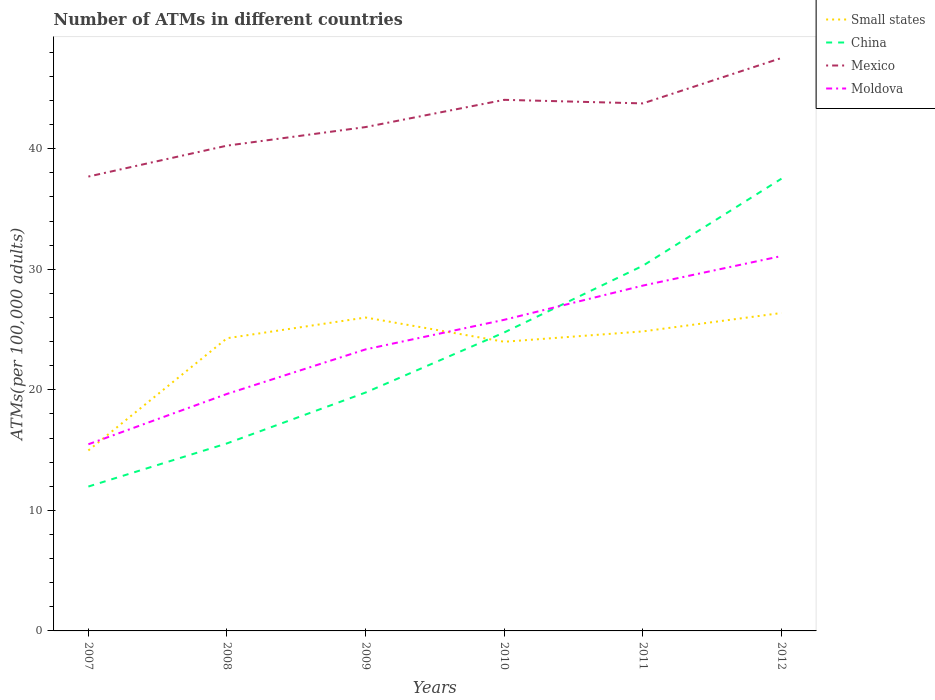Is the number of lines equal to the number of legend labels?
Offer a very short reply. Yes. Across all years, what is the maximum number of ATMs in Mexico?
Provide a short and direct response. 37.69. What is the total number of ATMs in Small states in the graph?
Make the answer very short. -0.38. What is the difference between the highest and the second highest number of ATMs in Small states?
Offer a terse response. 11.4. What is the difference between the highest and the lowest number of ATMs in Small states?
Provide a short and direct response. 5. How many lines are there?
Provide a short and direct response. 4. How many years are there in the graph?
Provide a succinct answer. 6. Are the values on the major ticks of Y-axis written in scientific E-notation?
Provide a succinct answer. No. Does the graph contain any zero values?
Provide a short and direct response. No. Where does the legend appear in the graph?
Keep it short and to the point. Top right. How many legend labels are there?
Offer a very short reply. 4. What is the title of the graph?
Make the answer very short. Number of ATMs in different countries. What is the label or title of the Y-axis?
Offer a terse response. ATMs(per 100,0 adults). What is the ATMs(per 100,000 adults) in Small states in 2007?
Make the answer very short. 14.97. What is the ATMs(per 100,000 adults) in China in 2007?
Your answer should be very brief. 11.98. What is the ATMs(per 100,000 adults) of Mexico in 2007?
Give a very brief answer. 37.69. What is the ATMs(per 100,000 adults) of Moldova in 2007?
Offer a very short reply. 15.48. What is the ATMs(per 100,000 adults) in Small states in 2008?
Provide a succinct answer. 24.28. What is the ATMs(per 100,000 adults) in China in 2008?
Your answer should be very brief. 15.55. What is the ATMs(per 100,000 adults) of Mexico in 2008?
Ensure brevity in your answer.  40.25. What is the ATMs(per 100,000 adults) in Moldova in 2008?
Offer a very short reply. 19.66. What is the ATMs(per 100,000 adults) in Small states in 2009?
Ensure brevity in your answer.  26. What is the ATMs(per 100,000 adults) in China in 2009?
Your answer should be very brief. 19.77. What is the ATMs(per 100,000 adults) of Mexico in 2009?
Make the answer very short. 41.79. What is the ATMs(per 100,000 adults) in Moldova in 2009?
Provide a short and direct response. 23.35. What is the ATMs(per 100,000 adults) of Small states in 2010?
Provide a short and direct response. 23.99. What is the ATMs(per 100,000 adults) of China in 2010?
Your response must be concise. 24.76. What is the ATMs(per 100,000 adults) of Mexico in 2010?
Your answer should be very brief. 44.05. What is the ATMs(per 100,000 adults) in Moldova in 2010?
Your response must be concise. 25.81. What is the ATMs(per 100,000 adults) of Small states in 2011?
Provide a succinct answer. 24.84. What is the ATMs(per 100,000 adults) of China in 2011?
Offer a very short reply. 30.29. What is the ATMs(per 100,000 adults) of Mexico in 2011?
Ensure brevity in your answer.  43.76. What is the ATMs(per 100,000 adults) in Moldova in 2011?
Offer a very short reply. 28.64. What is the ATMs(per 100,000 adults) in Small states in 2012?
Your response must be concise. 26.37. What is the ATMs(per 100,000 adults) in China in 2012?
Your response must be concise. 37.51. What is the ATMs(per 100,000 adults) in Mexico in 2012?
Ensure brevity in your answer.  47.52. What is the ATMs(per 100,000 adults) in Moldova in 2012?
Ensure brevity in your answer.  31.1. Across all years, what is the maximum ATMs(per 100,000 adults) in Small states?
Ensure brevity in your answer.  26.37. Across all years, what is the maximum ATMs(per 100,000 adults) of China?
Offer a terse response. 37.51. Across all years, what is the maximum ATMs(per 100,000 adults) of Mexico?
Offer a very short reply. 47.52. Across all years, what is the maximum ATMs(per 100,000 adults) in Moldova?
Make the answer very short. 31.1. Across all years, what is the minimum ATMs(per 100,000 adults) of Small states?
Provide a succinct answer. 14.97. Across all years, what is the minimum ATMs(per 100,000 adults) of China?
Keep it short and to the point. 11.98. Across all years, what is the minimum ATMs(per 100,000 adults) of Mexico?
Provide a succinct answer. 37.69. Across all years, what is the minimum ATMs(per 100,000 adults) of Moldova?
Your answer should be very brief. 15.48. What is the total ATMs(per 100,000 adults) of Small states in the graph?
Offer a very short reply. 140.44. What is the total ATMs(per 100,000 adults) of China in the graph?
Your response must be concise. 139.86. What is the total ATMs(per 100,000 adults) of Mexico in the graph?
Your answer should be compact. 255.06. What is the total ATMs(per 100,000 adults) of Moldova in the graph?
Offer a terse response. 144.04. What is the difference between the ATMs(per 100,000 adults) of Small states in 2007 and that in 2008?
Provide a succinct answer. -9.31. What is the difference between the ATMs(per 100,000 adults) in China in 2007 and that in 2008?
Provide a short and direct response. -3.58. What is the difference between the ATMs(per 100,000 adults) of Mexico in 2007 and that in 2008?
Ensure brevity in your answer.  -2.56. What is the difference between the ATMs(per 100,000 adults) in Moldova in 2007 and that in 2008?
Offer a very short reply. -4.18. What is the difference between the ATMs(per 100,000 adults) of Small states in 2007 and that in 2009?
Give a very brief answer. -11.03. What is the difference between the ATMs(per 100,000 adults) of China in 2007 and that in 2009?
Provide a succinct answer. -7.8. What is the difference between the ATMs(per 100,000 adults) in Mexico in 2007 and that in 2009?
Your answer should be compact. -4.11. What is the difference between the ATMs(per 100,000 adults) in Moldova in 2007 and that in 2009?
Offer a terse response. -7.87. What is the difference between the ATMs(per 100,000 adults) of Small states in 2007 and that in 2010?
Offer a terse response. -9.02. What is the difference between the ATMs(per 100,000 adults) of China in 2007 and that in 2010?
Keep it short and to the point. -12.78. What is the difference between the ATMs(per 100,000 adults) of Mexico in 2007 and that in 2010?
Offer a terse response. -6.37. What is the difference between the ATMs(per 100,000 adults) of Moldova in 2007 and that in 2010?
Provide a short and direct response. -10.32. What is the difference between the ATMs(per 100,000 adults) in Small states in 2007 and that in 2011?
Offer a terse response. -9.87. What is the difference between the ATMs(per 100,000 adults) of China in 2007 and that in 2011?
Make the answer very short. -18.31. What is the difference between the ATMs(per 100,000 adults) in Mexico in 2007 and that in 2011?
Give a very brief answer. -6.07. What is the difference between the ATMs(per 100,000 adults) of Moldova in 2007 and that in 2011?
Your response must be concise. -13.16. What is the difference between the ATMs(per 100,000 adults) of Small states in 2007 and that in 2012?
Your answer should be very brief. -11.4. What is the difference between the ATMs(per 100,000 adults) of China in 2007 and that in 2012?
Provide a short and direct response. -25.54. What is the difference between the ATMs(per 100,000 adults) of Mexico in 2007 and that in 2012?
Ensure brevity in your answer.  -9.84. What is the difference between the ATMs(per 100,000 adults) in Moldova in 2007 and that in 2012?
Provide a succinct answer. -15.61. What is the difference between the ATMs(per 100,000 adults) of Small states in 2008 and that in 2009?
Your answer should be compact. -1.72. What is the difference between the ATMs(per 100,000 adults) in China in 2008 and that in 2009?
Your response must be concise. -4.22. What is the difference between the ATMs(per 100,000 adults) in Mexico in 2008 and that in 2009?
Offer a terse response. -1.54. What is the difference between the ATMs(per 100,000 adults) of Moldova in 2008 and that in 2009?
Provide a short and direct response. -3.69. What is the difference between the ATMs(per 100,000 adults) of Small states in 2008 and that in 2010?
Your answer should be compact. 0.29. What is the difference between the ATMs(per 100,000 adults) of China in 2008 and that in 2010?
Your answer should be compact. -9.2. What is the difference between the ATMs(per 100,000 adults) of Mexico in 2008 and that in 2010?
Offer a terse response. -3.8. What is the difference between the ATMs(per 100,000 adults) in Moldova in 2008 and that in 2010?
Your answer should be compact. -6.15. What is the difference between the ATMs(per 100,000 adults) of Small states in 2008 and that in 2011?
Offer a very short reply. -0.57. What is the difference between the ATMs(per 100,000 adults) in China in 2008 and that in 2011?
Ensure brevity in your answer.  -14.73. What is the difference between the ATMs(per 100,000 adults) of Mexico in 2008 and that in 2011?
Keep it short and to the point. -3.5. What is the difference between the ATMs(per 100,000 adults) of Moldova in 2008 and that in 2011?
Your response must be concise. -8.99. What is the difference between the ATMs(per 100,000 adults) of Small states in 2008 and that in 2012?
Provide a succinct answer. -2.09. What is the difference between the ATMs(per 100,000 adults) in China in 2008 and that in 2012?
Give a very brief answer. -21.96. What is the difference between the ATMs(per 100,000 adults) of Mexico in 2008 and that in 2012?
Your answer should be very brief. -7.27. What is the difference between the ATMs(per 100,000 adults) in Moldova in 2008 and that in 2012?
Offer a very short reply. -11.44. What is the difference between the ATMs(per 100,000 adults) of Small states in 2009 and that in 2010?
Make the answer very short. 2.01. What is the difference between the ATMs(per 100,000 adults) in China in 2009 and that in 2010?
Offer a terse response. -4.98. What is the difference between the ATMs(per 100,000 adults) of Mexico in 2009 and that in 2010?
Offer a terse response. -2.26. What is the difference between the ATMs(per 100,000 adults) of Moldova in 2009 and that in 2010?
Ensure brevity in your answer.  -2.45. What is the difference between the ATMs(per 100,000 adults) in Small states in 2009 and that in 2011?
Offer a very short reply. 1.15. What is the difference between the ATMs(per 100,000 adults) in China in 2009 and that in 2011?
Offer a very short reply. -10.51. What is the difference between the ATMs(per 100,000 adults) of Mexico in 2009 and that in 2011?
Your response must be concise. -1.96. What is the difference between the ATMs(per 100,000 adults) of Moldova in 2009 and that in 2011?
Ensure brevity in your answer.  -5.29. What is the difference between the ATMs(per 100,000 adults) in Small states in 2009 and that in 2012?
Your response must be concise. -0.38. What is the difference between the ATMs(per 100,000 adults) in China in 2009 and that in 2012?
Offer a very short reply. -17.74. What is the difference between the ATMs(per 100,000 adults) of Mexico in 2009 and that in 2012?
Provide a short and direct response. -5.73. What is the difference between the ATMs(per 100,000 adults) in Moldova in 2009 and that in 2012?
Your response must be concise. -7.74. What is the difference between the ATMs(per 100,000 adults) of Small states in 2010 and that in 2011?
Your response must be concise. -0.86. What is the difference between the ATMs(per 100,000 adults) in China in 2010 and that in 2011?
Offer a terse response. -5.53. What is the difference between the ATMs(per 100,000 adults) in Mexico in 2010 and that in 2011?
Provide a succinct answer. 0.3. What is the difference between the ATMs(per 100,000 adults) of Moldova in 2010 and that in 2011?
Offer a very short reply. -2.84. What is the difference between the ATMs(per 100,000 adults) in Small states in 2010 and that in 2012?
Your answer should be compact. -2.39. What is the difference between the ATMs(per 100,000 adults) in China in 2010 and that in 2012?
Your response must be concise. -12.76. What is the difference between the ATMs(per 100,000 adults) of Mexico in 2010 and that in 2012?
Provide a short and direct response. -3.47. What is the difference between the ATMs(per 100,000 adults) in Moldova in 2010 and that in 2012?
Give a very brief answer. -5.29. What is the difference between the ATMs(per 100,000 adults) of Small states in 2011 and that in 2012?
Your answer should be compact. -1.53. What is the difference between the ATMs(per 100,000 adults) of China in 2011 and that in 2012?
Provide a succinct answer. -7.22. What is the difference between the ATMs(per 100,000 adults) in Mexico in 2011 and that in 2012?
Provide a short and direct response. -3.77. What is the difference between the ATMs(per 100,000 adults) in Moldova in 2011 and that in 2012?
Offer a terse response. -2.45. What is the difference between the ATMs(per 100,000 adults) in Small states in 2007 and the ATMs(per 100,000 adults) in China in 2008?
Offer a very short reply. -0.58. What is the difference between the ATMs(per 100,000 adults) of Small states in 2007 and the ATMs(per 100,000 adults) of Mexico in 2008?
Keep it short and to the point. -25.28. What is the difference between the ATMs(per 100,000 adults) in Small states in 2007 and the ATMs(per 100,000 adults) in Moldova in 2008?
Offer a terse response. -4.69. What is the difference between the ATMs(per 100,000 adults) of China in 2007 and the ATMs(per 100,000 adults) of Mexico in 2008?
Give a very brief answer. -28.28. What is the difference between the ATMs(per 100,000 adults) in China in 2007 and the ATMs(per 100,000 adults) in Moldova in 2008?
Provide a short and direct response. -7.68. What is the difference between the ATMs(per 100,000 adults) in Mexico in 2007 and the ATMs(per 100,000 adults) in Moldova in 2008?
Your answer should be compact. 18.03. What is the difference between the ATMs(per 100,000 adults) in Small states in 2007 and the ATMs(per 100,000 adults) in China in 2009?
Make the answer very short. -4.8. What is the difference between the ATMs(per 100,000 adults) of Small states in 2007 and the ATMs(per 100,000 adults) of Mexico in 2009?
Offer a very short reply. -26.82. What is the difference between the ATMs(per 100,000 adults) of Small states in 2007 and the ATMs(per 100,000 adults) of Moldova in 2009?
Your answer should be compact. -8.38. What is the difference between the ATMs(per 100,000 adults) of China in 2007 and the ATMs(per 100,000 adults) of Mexico in 2009?
Ensure brevity in your answer.  -29.82. What is the difference between the ATMs(per 100,000 adults) in China in 2007 and the ATMs(per 100,000 adults) in Moldova in 2009?
Your answer should be compact. -11.38. What is the difference between the ATMs(per 100,000 adults) in Mexico in 2007 and the ATMs(per 100,000 adults) in Moldova in 2009?
Offer a terse response. 14.33. What is the difference between the ATMs(per 100,000 adults) of Small states in 2007 and the ATMs(per 100,000 adults) of China in 2010?
Your answer should be very brief. -9.79. What is the difference between the ATMs(per 100,000 adults) of Small states in 2007 and the ATMs(per 100,000 adults) of Mexico in 2010?
Ensure brevity in your answer.  -29.08. What is the difference between the ATMs(per 100,000 adults) of Small states in 2007 and the ATMs(per 100,000 adults) of Moldova in 2010?
Ensure brevity in your answer.  -10.84. What is the difference between the ATMs(per 100,000 adults) in China in 2007 and the ATMs(per 100,000 adults) in Mexico in 2010?
Offer a terse response. -32.08. What is the difference between the ATMs(per 100,000 adults) in China in 2007 and the ATMs(per 100,000 adults) in Moldova in 2010?
Make the answer very short. -13.83. What is the difference between the ATMs(per 100,000 adults) in Mexico in 2007 and the ATMs(per 100,000 adults) in Moldova in 2010?
Ensure brevity in your answer.  11.88. What is the difference between the ATMs(per 100,000 adults) of Small states in 2007 and the ATMs(per 100,000 adults) of China in 2011?
Give a very brief answer. -15.32. What is the difference between the ATMs(per 100,000 adults) of Small states in 2007 and the ATMs(per 100,000 adults) of Mexico in 2011?
Give a very brief answer. -28.79. What is the difference between the ATMs(per 100,000 adults) of Small states in 2007 and the ATMs(per 100,000 adults) of Moldova in 2011?
Provide a short and direct response. -13.67. What is the difference between the ATMs(per 100,000 adults) in China in 2007 and the ATMs(per 100,000 adults) in Mexico in 2011?
Your response must be concise. -31.78. What is the difference between the ATMs(per 100,000 adults) of China in 2007 and the ATMs(per 100,000 adults) of Moldova in 2011?
Offer a very short reply. -16.67. What is the difference between the ATMs(per 100,000 adults) of Mexico in 2007 and the ATMs(per 100,000 adults) of Moldova in 2011?
Give a very brief answer. 9.04. What is the difference between the ATMs(per 100,000 adults) of Small states in 2007 and the ATMs(per 100,000 adults) of China in 2012?
Offer a very short reply. -22.54. What is the difference between the ATMs(per 100,000 adults) of Small states in 2007 and the ATMs(per 100,000 adults) of Mexico in 2012?
Give a very brief answer. -32.55. What is the difference between the ATMs(per 100,000 adults) in Small states in 2007 and the ATMs(per 100,000 adults) in Moldova in 2012?
Keep it short and to the point. -16.13. What is the difference between the ATMs(per 100,000 adults) of China in 2007 and the ATMs(per 100,000 adults) of Mexico in 2012?
Your response must be concise. -35.55. What is the difference between the ATMs(per 100,000 adults) of China in 2007 and the ATMs(per 100,000 adults) of Moldova in 2012?
Offer a very short reply. -19.12. What is the difference between the ATMs(per 100,000 adults) in Mexico in 2007 and the ATMs(per 100,000 adults) in Moldova in 2012?
Provide a succinct answer. 6.59. What is the difference between the ATMs(per 100,000 adults) of Small states in 2008 and the ATMs(per 100,000 adults) of China in 2009?
Ensure brevity in your answer.  4.5. What is the difference between the ATMs(per 100,000 adults) of Small states in 2008 and the ATMs(per 100,000 adults) of Mexico in 2009?
Provide a short and direct response. -17.52. What is the difference between the ATMs(per 100,000 adults) of Small states in 2008 and the ATMs(per 100,000 adults) of Moldova in 2009?
Offer a terse response. 0.92. What is the difference between the ATMs(per 100,000 adults) of China in 2008 and the ATMs(per 100,000 adults) of Mexico in 2009?
Make the answer very short. -26.24. What is the difference between the ATMs(per 100,000 adults) of China in 2008 and the ATMs(per 100,000 adults) of Moldova in 2009?
Your answer should be very brief. -7.8. What is the difference between the ATMs(per 100,000 adults) in Mexico in 2008 and the ATMs(per 100,000 adults) in Moldova in 2009?
Offer a terse response. 16.9. What is the difference between the ATMs(per 100,000 adults) of Small states in 2008 and the ATMs(per 100,000 adults) of China in 2010?
Make the answer very short. -0.48. What is the difference between the ATMs(per 100,000 adults) in Small states in 2008 and the ATMs(per 100,000 adults) in Mexico in 2010?
Your response must be concise. -19.78. What is the difference between the ATMs(per 100,000 adults) of Small states in 2008 and the ATMs(per 100,000 adults) of Moldova in 2010?
Offer a terse response. -1.53. What is the difference between the ATMs(per 100,000 adults) of China in 2008 and the ATMs(per 100,000 adults) of Mexico in 2010?
Provide a succinct answer. -28.5. What is the difference between the ATMs(per 100,000 adults) of China in 2008 and the ATMs(per 100,000 adults) of Moldova in 2010?
Provide a succinct answer. -10.25. What is the difference between the ATMs(per 100,000 adults) in Mexico in 2008 and the ATMs(per 100,000 adults) in Moldova in 2010?
Keep it short and to the point. 14.45. What is the difference between the ATMs(per 100,000 adults) in Small states in 2008 and the ATMs(per 100,000 adults) in China in 2011?
Your response must be concise. -6.01. What is the difference between the ATMs(per 100,000 adults) of Small states in 2008 and the ATMs(per 100,000 adults) of Mexico in 2011?
Provide a short and direct response. -19.48. What is the difference between the ATMs(per 100,000 adults) of Small states in 2008 and the ATMs(per 100,000 adults) of Moldova in 2011?
Keep it short and to the point. -4.37. What is the difference between the ATMs(per 100,000 adults) of China in 2008 and the ATMs(per 100,000 adults) of Mexico in 2011?
Ensure brevity in your answer.  -28.2. What is the difference between the ATMs(per 100,000 adults) in China in 2008 and the ATMs(per 100,000 adults) in Moldova in 2011?
Make the answer very short. -13.09. What is the difference between the ATMs(per 100,000 adults) of Mexico in 2008 and the ATMs(per 100,000 adults) of Moldova in 2011?
Offer a terse response. 11.61. What is the difference between the ATMs(per 100,000 adults) in Small states in 2008 and the ATMs(per 100,000 adults) in China in 2012?
Provide a succinct answer. -13.24. What is the difference between the ATMs(per 100,000 adults) of Small states in 2008 and the ATMs(per 100,000 adults) of Mexico in 2012?
Your answer should be very brief. -23.25. What is the difference between the ATMs(per 100,000 adults) of Small states in 2008 and the ATMs(per 100,000 adults) of Moldova in 2012?
Provide a succinct answer. -6.82. What is the difference between the ATMs(per 100,000 adults) in China in 2008 and the ATMs(per 100,000 adults) in Mexico in 2012?
Provide a succinct answer. -31.97. What is the difference between the ATMs(per 100,000 adults) in China in 2008 and the ATMs(per 100,000 adults) in Moldova in 2012?
Your answer should be compact. -15.54. What is the difference between the ATMs(per 100,000 adults) in Mexico in 2008 and the ATMs(per 100,000 adults) in Moldova in 2012?
Give a very brief answer. 9.16. What is the difference between the ATMs(per 100,000 adults) in Small states in 2009 and the ATMs(per 100,000 adults) in China in 2010?
Your answer should be compact. 1.24. What is the difference between the ATMs(per 100,000 adults) of Small states in 2009 and the ATMs(per 100,000 adults) of Mexico in 2010?
Offer a very short reply. -18.06. What is the difference between the ATMs(per 100,000 adults) of Small states in 2009 and the ATMs(per 100,000 adults) of Moldova in 2010?
Provide a short and direct response. 0.19. What is the difference between the ATMs(per 100,000 adults) in China in 2009 and the ATMs(per 100,000 adults) in Mexico in 2010?
Keep it short and to the point. -24.28. What is the difference between the ATMs(per 100,000 adults) of China in 2009 and the ATMs(per 100,000 adults) of Moldova in 2010?
Offer a terse response. -6.03. What is the difference between the ATMs(per 100,000 adults) in Mexico in 2009 and the ATMs(per 100,000 adults) in Moldova in 2010?
Your answer should be very brief. 15.99. What is the difference between the ATMs(per 100,000 adults) in Small states in 2009 and the ATMs(per 100,000 adults) in China in 2011?
Keep it short and to the point. -4.29. What is the difference between the ATMs(per 100,000 adults) in Small states in 2009 and the ATMs(per 100,000 adults) in Mexico in 2011?
Provide a short and direct response. -17.76. What is the difference between the ATMs(per 100,000 adults) of Small states in 2009 and the ATMs(per 100,000 adults) of Moldova in 2011?
Provide a short and direct response. -2.65. What is the difference between the ATMs(per 100,000 adults) in China in 2009 and the ATMs(per 100,000 adults) in Mexico in 2011?
Provide a short and direct response. -23.98. What is the difference between the ATMs(per 100,000 adults) in China in 2009 and the ATMs(per 100,000 adults) in Moldova in 2011?
Your answer should be very brief. -8.87. What is the difference between the ATMs(per 100,000 adults) in Mexico in 2009 and the ATMs(per 100,000 adults) in Moldova in 2011?
Make the answer very short. 13.15. What is the difference between the ATMs(per 100,000 adults) of Small states in 2009 and the ATMs(per 100,000 adults) of China in 2012?
Offer a terse response. -11.52. What is the difference between the ATMs(per 100,000 adults) of Small states in 2009 and the ATMs(per 100,000 adults) of Mexico in 2012?
Offer a terse response. -21.53. What is the difference between the ATMs(per 100,000 adults) of Small states in 2009 and the ATMs(per 100,000 adults) of Moldova in 2012?
Provide a short and direct response. -5.1. What is the difference between the ATMs(per 100,000 adults) in China in 2009 and the ATMs(per 100,000 adults) in Mexico in 2012?
Your response must be concise. -27.75. What is the difference between the ATMs(per 100,000 adults) in China in 2009 and the ATMs(per 100,000 adults) in Moldova in 2012?
Offer a terse response. -11.32. What is the difference between the ATMs(per 100,000 adults) in Mexico in 2009 and the ATMs(per 100,000 adults) in Moldova in 2012?
Keep it short and to the point. 10.7. What is the difference between the ATMs(per 100,000 adults) in Small states in 2010 and the ATMs(per 100,000 adults) in China in 2011?
Provide a short and direct response. -6.3. What is the difference between the ATMs(per 100,000 adults) of Small states in 2010 and the ATMs(per 100,000 adults) of Mexico in 2011?
Ensure brevity in your answer.  -19.77. What is the difference between the ATMs(per 100,000 adults) of Small states in 2010 and the ATMs(per 100,000 adults) of Moldova in 2011?
Provide a succinct answer. -4.66. What is the difference between the ATMs(per 100,000 adults) in China in 2010 and the ATMs(per 100,000 adults) in Mexico in 2011?
Your answer should be compact. -19. What is the difference between the ATMs(per 100,000 adults) of China in 2010 and the ATMs(per 100,000 adults) of Moldova in 2011?
Your response must be concise. -3.89. What is the difference between the ATMs(per 100,000 adults) in Mexico in 2010 and the ATMs(per 100,000 adults) in Moldova in 2011?
Offer a terse response. 15.41. What is the difference between the ATMs(per 100,000 adults) in Small states in 2010 and the ATMs(per 100,000 adults) in China in 2012?
Your answer should be very brief. -13.53. What is the difference between the ATMs(per 100,000 adults) in Small states in 2010 and the ATMs(per 100,000 adults) in Mexico in 2012?
Give a very brief answer. -23.54. What is the difference between the ATMs(per 100,000 adults) in Small states in 2010 and the ATMs(per 100,000 adults) in Moldova in 2012?
Provide a succinct answer. -7.11. What is the difference between the ATMs(per 100,000 adults) in China in 2010 and the ATMs(per 100,000 adults) in Mexico in 2012?
Your answer should be compact. -22.77. What is the difference between the ATMs(per 100,000 adults) in China in 2010 and the ATMs(per 100,000 adults) in Moldova in 2012?
Your answer should be compact. -6.34. What is the difference between the ATMs(per 100,000 adults) of Mexico in 2010 and the ATMs(per 100,000 adults) of Moldova in 2012?
Your response must be concise. 12.96. What is the difference between the ATMs(per 100,000 adults) in Small states in 2011 and the ATMs(per 100,000 adults) in China in 2012?
Your answer should be very brief. -12.67. What is the difference between the ATMs(per 100,000 adults) in Small states in 2011 and the ATMs(per 100,000 adults) in Mexico in 2012?
Give a very brief answer. -22.68. What is the difference between the ATMs(per 100,000 adults) of Small states in 2011 and the ATMs(per 100,000 adults) of Moldova in 2012?
Offer a very short reply. -6.25. What is the difference between the ATMs(per 100,000 adults) of China in 2011 and the ATMs(per 100,000 adults) of Mexico in 2012?
Keep it short and to the point. -17.23. What is the difference between the ATMs(per 100,000 adults) in China in 2011 and the ATMs(per 100,000 adults) in Moldova in 2012?
Offer a very short reply. -0.81. What is the difference between the ATMs(per 100,000 adults) of Mexico in 2011 and the ATMs(per 100,000 adults) of Moldova in 2012?
Give a very brief answer. 12.66. What is the average ATMs(per 100,000 adults) of Small states per year?
Provide a succinct answer. 23.41. What is the average ATMs(per 100,000 adults) of China per year?
Make the answer very short. 23.31. What is the average ATMs(per 100,000 adults) of Mexico per year?
Your answer should be very brief. 42.51. What is the average ATMs(per 100,000 adults) of Moldova per year?
Your response must be concise. 24.01. In the year 2007, what is the difference between the ATMs(per 100,000 adults) in Small states and ATMs(per 100,000 adults) in China?
Your answer should be very brief. 2.99. In the year 2007, what is the difference between the ATMs(per 100,000 adults) in Small states and ATMs(per 100,000 adults) in Mexico?
Your answer should be very brief. -22.72. In the year 2007, what is the difference between the ATMs(per 100,000 adults) in Small states and ATMs(per 100,000 adults) in Moldova?
Your answer should be very brief. -0.51. In the year 2007, what is the difference between the ATMs(per 100,000 adults) of China and ATMs(per 100,000 adults) of Mexico?
Your answer should be compact. -25.71. In the year 2007, what is the difference between the ATMs(per 100,000 adults) of China and ATMs(per 100,000 adults) of Moldova?
Your response must be concise. -3.51. In the year 2007, what is the difference between the ATMs(per 100,000 adults) of Mexico and ATMs(per 100,000 adults) of Moldova?
Keep it short and to the point. 22.21. In the year 2008, what is the difference between the ATMs(per 100,000 adults) in Small states and ATMs(per 100,000 adults) in China?
Your answer should be very brief. 8.72. In the year 2008, what is the difference between the ATMs(per 100,000 adults) in Small states and ATMs(per 100,000 adults) in Mexico?
Give a very brief answer. -15.97. In the year 2008, what is the difference between the ATMs(per 100,000 adults) in Small states and ATMs(per 100,000 adults) in Moldova?
Your answer should be compact. 4.62. In the year 2008, what is the difference between the ATMs(per 100,000 adults) of China and ATMs(per 100,000 adults) of Mexico?
Keep it short and to the point. -24.7. In the year 2008, what is the difference between the ATMs(per 100,000 adults) of China and ATMs(per 100,000 adults) of Moldova?
Your response must be concise. -4.1. In the year 2008, what is the difference between the ATMs(per 100,000 adults) in Mexico and ATMs(per 100,000 adults) in Moldova?
Give a very brief answer. 20.59. In the year 2009, what is the difference between the ATMs(per 100,000 adults) of Small states and ATMs(per 100,000 adults) of China?
Your response must be concise. 6.22. In the year 2009, what is the difference between the ATMs(per 100,000 adults) of Small states and ATMs(per 100,000 adults) of Mexico?
Give a very brief answer. -15.8. In the year 2009, what is the difference between the ATMs(per 100,000 adults) of Small states and ATMs(per 100,000 adults) of Moldova?
Offer a very short reply. 2.64. In the year 2009, what is the difference between the ATMs(per 100,000 adults) of China and ATMs(per 100,000 adults) of Mexico?
Give a very brief answer. -22.02. In the year 2009, what is the difference between the ATMs(per 100,000 adults) of China and ATMs(per 100,000 adults) of Moldova?
Your response must be concise. -3.58. In the year 2009, what is the difference between the ATMs(per 100,000 adults) of Mexico and ATMs(per 100,000 adults) of Moldova?
Keep it short and to the point. 18.44. In the year 2010, what is the difference between the ATMs(per 100,000 adults) of Small states and ATMs(per 100,000 adults) of China?
Make the answer very short. -0.77. In the year 2010, what is the difference between the ATMs(per 100,000 adults) of Small states and ATMs(per 100,000 adults) of Mexico?
Ensure brevity in your answer.  -20.07. In the year 2010, what is the difference between the ATMs(per 100,000 adults) of Small states and ATMs(per 100,000 adults) of Moldova?
Make the answer very short. -1.82. In the year 2010, what is the difference between the ATMs(per 100,000 adults) in China and ATMs(per 100,000 adults) in Mexico?
Ensure brevity in your answer.  -19.3. In the year 2010, what is the difference between the ATMs(per 100,000 adults) of China and ATMs(per 100,000 adults) of Moldova?
Your response must be concise. -1.05. In the year 2010, what is the difference between the ATMs(per 100,000 adults) in Mexico and ATMs(per 100,000 adults) in Moldova?
Ensure brevity in your answer.  18.25. In the year 2011, what is the difference between the ATMs(per 100,000 adults) in Small states and ATMs(per 100,000 adults) in China?
Your answer should be very brief. -5.45. In the year 2011, what is the difference between the ATMs(per 100,000 adults) of Small states and ATMs(per 100,000 adults) of Mexico?
Your response must be concise. -18.91. In the year 2011, what is the difference between the ATMs(per 100,000 adults) in Small states and ATMs(per 100,000 adults) in Moldova?
Offer a terse response. -3.8. In the year 2011, what is the difference between the ATMs(per 100,000 adults) of China and ATMs(per 100,000 adults) of Mexico?
Ensure brevity in your answer.  -13.47. In the year 2011, what is the difference between the ATMs(per 100,000 adults) of China and ATMs(per 100,000 adults) of Moldova?
Keep it short and to the point. 1.65. In the year 2011, what is the difference between the ATMs(per 100,000 adults) in Mexico and ATMs(per 100,000 adults) in Moldova?
Offer a very short reply. 15.11. In the year 2012, what is the difference between the ATMs(per 100,000 adults) in Small states and ATMs(per 100,000 adults) in China?
Your answer should be very brief. -11.14. In the year 2012, what is the difference between the ATMs(per 100,000 adults) of Small states and ATMs(per 100,000 adults) of Mexico?
Provide a succinct answer. -21.15. In the year 2012, what is the difference between the ATMs(per 100,000 adults) in Small states and ATMs(per 100,000 adults) in Moldova?
Provide a succinct answer. -4.72. In the year 2012, what is the difference between the ATMs(per 100,000 adults) in China and ATMs(per 100,000 adults) in Mexico?
Ensure brevity in your answer.  -10.01. In the year 2012, what is the difference between the ATMs(per 100,000 adults) in China and ATMs(per 100,000 adults) in Moldova?
Give a very brief answer. 6.42. In the year 2012, what is the difference between the ATMs(per 100,000 adults) in Mexico and ATMs(per 100,000 adults) in Moldova?
Your response must be concise. 16.43. What is the ratio of the ATMs(per 100,000 adults) of Small states in 2007 to that in 2008?
Provide a short and direct response. 0.62. What is the ratio of the ATMs(per 100,000 adults) in China in 2007 to that in 2008?
Offer a very short reply. 0.77. What is the ratio of the ATMs(per 100,000 adults) of Mexico in 2007 to that in 2008?
Offer a very short reply. 0.94. What is the ratio of the ATMs(per 100,000 adults) of Moldova in 2007 to that in 2008?
Provide a succinct answer. 0.79. What is the ratio of the ATMs(per 100,000 adults) of Small states in 2007 to that in 2009?
Offer a very short reply. 0.58. What is the ratio of the ATMs(per 100,000 adults) in China in 2007 to that in 2009?
Offer a terse response. 0.61. What is the ratio of the ATMs(per 100,000 adults) of Mexico in 2007 to that in 2009?
Your answer should be very brief. 0.9. What is the ratio of the ATMs(per 100,000 adults) of Moldova in 2007 to that in 2009?
Give a very brief answer. 0.66. What is the ratio of the ATMs(per 100,000 adults) in Small states in 2007 to that in 2010?
Ensure brevity in your answer.  0.62. What is the ratio of the ATMs(per 100,000 adults) of China in 2007 to that in 2010?
Give a very brief answer. 0.48. What is the ratio of the ATMs(per 100,000 adults) in Mexico in 2007 to that in 2010?
Provide a succinct answer. 0.86. What is the ratio of the ATMs(per 100,000 adults) of Moldova in 2007 to that in 2010?
Make the answer very short. 0.6. What is the ratio of the ATMs(per 100,000 adults) of Small states in 2007 to that in 2011?
Offer a very short reply. 0.6. What is the ratio of the ATMs(per 100,000 adults) in China in 2007 to that in 2011?
Keep it short and to the point. 0.4. What is the ratio of the ATMs(per 100,000 adults) of Mexico in 2007 to that in 2011?
Your response must be concise. 0.86. What is the ratio of the ATMs(per 100,000 adults) of Moldova in 2007 to that in 2011?
Keep it short and to the point. 0.54. What is the ratio of the ATMs(per 100,000 adults) in Small states in 2007 to that in 2012?
Offer a very short reply. 0.57. What is the ratio of the ATMs(per 100,000 adults) of China in 2007 to that in 2012?
Offer a terse response. 0.32. What is the ratio of the ATMs(per 100,000 adults) in Mexico in 2007 to that in 2012?
Give a very brief answer. 0.79. What is the ratio of the ATMs(per 100,000 adults) in Moldova in 2007 to that in 2012?
Your answer should be very brief. 0.5. What is the ratio of the ATMs(per 100,000 adults) of Small states in 2008 to that in 2009?
Provide a succinct answer. 0.93. What is the ratio of the ATMs(per 100,000 adults) of China in 2008 to that in 2009?
Provide a short and direct response. 0.79. What is the ratio of the ATMs(per 100,000 adults) of Mexico in 2008 to that in 2009?
Offer a terse response. 0.96. What is the ratio of the ATMs(per 100,000 adults) of Moldova in 2008 to that in 2009?
Your answer should be compact. 0.84. What is the ratio of the ATMs(per 100,000 adults) in Small states in 2008 to that in 2010?
Your answer should be very brief. 1.01. What is the ratio of the ATMs(per 100,000 adults) of China in 2008 to that in 2010?
Your answer should be very brief. 0.63. What is the ratio of the ATMs(per 100,000 adults) of Mexico in 2008 to that in 2010?
Your answer should be compact. 0.91. What is the ratio of the ATMs(per 100,000 adults) in Moldova in 2008 to that in 2010?
Your answer should be compact. 0.76. What is the ratio of the ATMs(per 100,000 adults) in Small states in 2008 to that in 2011?
Offer a terse response. 0.98. What is the ratio of the ATMs(per 100,000 adults) of China in 2008 to that in 2011?
Provide a short and direct response. 0.51. What is the ratio of the ATMs(per 100,000 adults) of Mexico in 2008 to that in 2011?
Your answer should be very brief. 0.92. What is the ratio of the ATMs(per 100,000 adults) in Moldova in 2008 to that in 2011?
Keep it short and to the point. 0.69. What is the ratio of the ATMs(per 100,000 adults) in Small states in 2008 to that in 2012?
Give a very brief answer. 0.92. What is the ratio of the ATMs(per 100,000 adults) of China in 2008 to that in 2012?
Your answer should be compact. 0.41. What is the ratio of the ATMs(per 100,000 adults) of Mexico in 2008 to that in 2012?
Your response must be concise. 0.85. What is the ratio of the ATMs(per 100,000 adults) in Moldova in 2008 to that in 2012?
Your answer should be very brief. 0.63. What is the ratio of the ATMs(per 100,000 adults) in Small states in 2009 to that in 2010?
Offer a very short reply. 1.08. What is the ratio of the ATMs(per 100,000 adults) of China in 2009 to that in 2010?
Your answer should be very brief. 0.8. What is the ratio of the ATMs(per 100,000 adults) of Mexico in 2009 to that in 2010?
Offer a terse response. 0.95. What is the ratio of the ATMs(per 100,000 adults) of Moldova in 2009 to that in 2010?
Your answer should be very brief. 0.9. What is the ratio of the ATMs(per 100,000 adults) in Small states in 2009 to that in 2011?
Provide a succinct answer. 1.05. What is the ratio of the ATMs(per 100,000 adults) in China in 2009 to that in 2011?
Your response must be concise. 0.65. What is the ratio of the ATMs(per 100,000 adults) in Mexico in 2009 to that in 2011?
Give a very brief answer. 0.96. What is the ratio of the ATMs(per 100,000 adults) in Moldova in 2009 to that in 2011?
Provide a succinct answer. 0.82. What is the ratio of the ATMs(per 100,000 adults) in Small states in 2009 to that in 2012?
Ensure brevity in your answer.  0.99. What is the ratio of the ATMs(per 100,000 adults) in China in 2009 to that in 2012?
Make the answer very short. 0.53. What is the ratio of the ATMs(per 100,000 adults) of Mexico in 2009 to that in 2012?
Provide a short and direct response. 0.88. What is the ratio of the ATMs(per 100,000 adults) in Moldova in 2009 to that in 2012?
Offer a very short reply. 0.75. What is the ratio of the ATMs(per 100,000 adults) in Small states in 2010 to that in 2011?
Give a very brief answer. 0.97. What is the ratio of the ATMs(per 100,000 adults) of China in 2010 to that in 2011?
Provide a succinct answer. 0.82. What is the ratio of the ATMs(per 100,000 adults) in Moldova in 2010 to that in 2011?
Your answer should be compact. 0.9. What is the ratio of the ATMs(per 100,000 adults) in Small states in 2010 to that in 2012?
Ensure brevity in your answer.  0.91. What is the ratio of the ATMs(per 100,000 adults) of China in 2010 to that in 2012?
Make the answer very short. 0.66. What is the ratio of the ATMs(per 100,000 adults) of Mexico in 2010 to that in 2012?
Make the answer very short. 0.93. What is the ratio of the ATMs(per 100,000 adults) of Moldova in 2010 to that in 2012?
Keep it short and to the point. 0.83. What is the ratio of the ATMs(per 100,000 adults) of Small states in 2011 to that in 2012?
Offer a very short reply. 0.94. What is the ratio of the ATMs(per 100,000 adults) of China in 2011 to that in 2012?
Ensure brevity in your answer.  0.81. What is the ratio of the ATMs(per 100,000 adults) of Mexico in 2011 to that in 2012?
Offer a terse response. 0.92. What is the ratio of the ATMs(per 100,000 adults) of Moldova in 2011 to that in 2012?
Give a very brief answer. 0.92. What is the difference between the highest and the second highest ATMs(per 100,000 adults) in Small states?
Your answer should be compact. 0.38. What is the difference between the highest and the second highest ATMs(per 100,000 adults) of China?
Your answer should be compact. 7.22. What is the difference between the highest and the second highest ATMs(per 100,000 adults) in Mexico?
Provide a succinct answer. 3.47. What is the difference between the highest and the second highest ATMs(per 100,000 adults) in Moldova?
Your response must be concise. 2.45. What is the difference between the highest and the lowest ATMs(per 100,000 adults) of Small states?
Provide a succinct answer. 11.4. What is the difference between the highest and the lowest ATMs(per 100,000 adults) in China?
Keep it short and to the point. 25.54. What is the difference between the highest and the lowest ATMs(per 100,000 adults) of Mexico?
Provide a short and direct response. 9.84. What is the difference between the highest and the lowest ATMs(per 100,000 adults) of Moldova?
Make the answer very short. 15.61. 